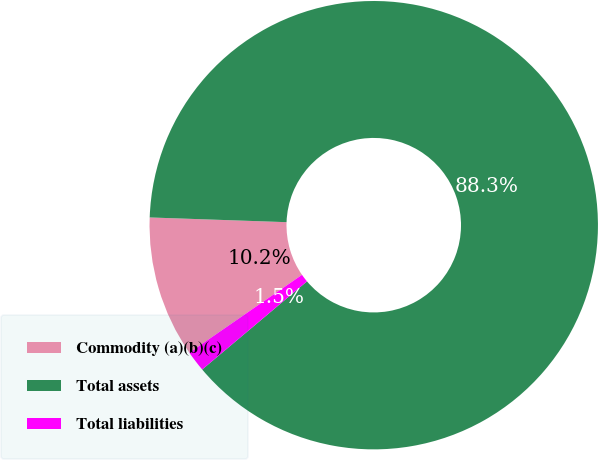Convert chart to OTSL. <chart><loc_0><loc_0><loc_500><loc_500><pie_chart><fcel>Commodity (a)(b)(c)<fcel>Total assets<fcel>Total liabilities<nl><fcel>10.18%<fcel>88.32%<fcel>1.5%<nl></chart> 